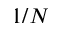Convert formula to latex. <formula><loc_0><loc_0><loc_500><loc_500>1 / N</formula> 